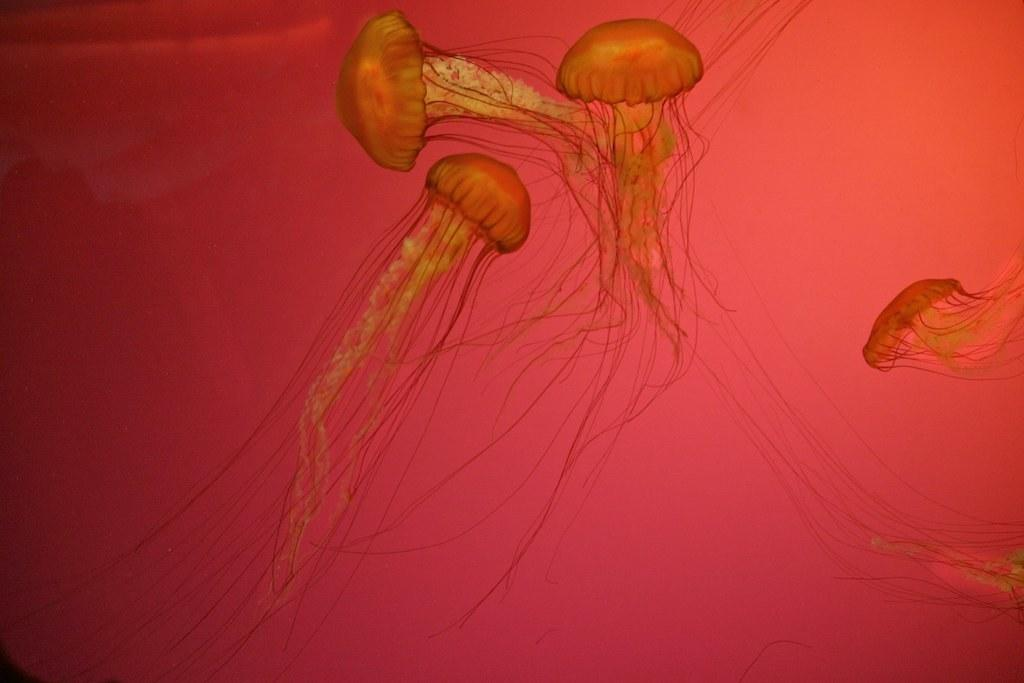What type of animals are present in the image? There are jellyfish in the image. What type of insurance is being advertised in the image? There is no insurance being advertised in the image; it features jellyfish. What toothpaste brand is being promoted in the image? There is no toothpaste brand being promoted in the image; it features jellyfish. 